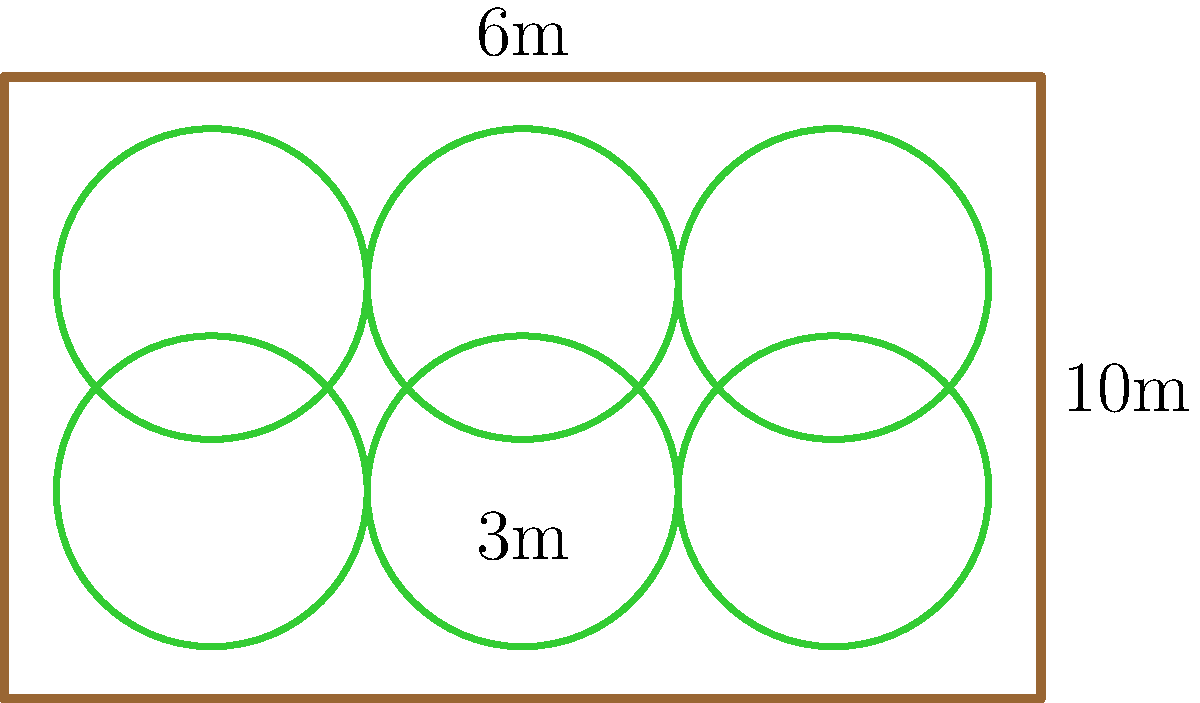In a rectangular permaculture garden plot measuring 10m by 6m, you want to arrange circular garden beds, each with a diameter of 3m. What is the maximum number of non-overlapping circular beds that can fit within the plot while maintaining at least 1m spacing between beds and from the plot edges? To solve this problem, let's follow these steps:

1. Understand the constraints:
   - Plot size: 10m x 6m
   - Circular bed diameter: 3m (radius = 1.5m)
   - Minimum spacing: 1m between beds and from edges

2. Calculate the effective space needed for each bed:
   - Diameter + spacing = 3m + 1m = 4m
   - This means each bed effectively occupies a 4m x 4m square

3. Determine how many beds can fit along the length (10m):
   - 10m ÷ 4m = 2.5
   - We can fit 2 beds along the length with 1m spacing on each side

4. Determine how many beds can fit along the width (6m):
   - 6m ÷ 4m = 1.5
   - We can fit 1 bed along the width with 1.5m spacing on each side

5. Calculate the total number of beds:
   - Number of beds = 2 (along length) x 1 (along width) = 2

6. Optimize the arrangement:
   - We can fit an additional row of beds by adjusting the spacing
   - New arrangement: 3 beds along length, 2 beds along width
   - This gives us 3 x 2 = 6 beds in total

7. Verify the new arrangement:
   - Along length: 3 beds of 3m each + 4 spaces of 1m each = 9m + 1m = 10m
   - Along width: 2 beds of 3m each + 3 spaces of 1m each = 6m + 0m = 6m

Therefore, the maximum number of non-overlapping circular beds that can fit within the plot while maintaining at least 1m spacing is 6.
Answer: 6 beds 